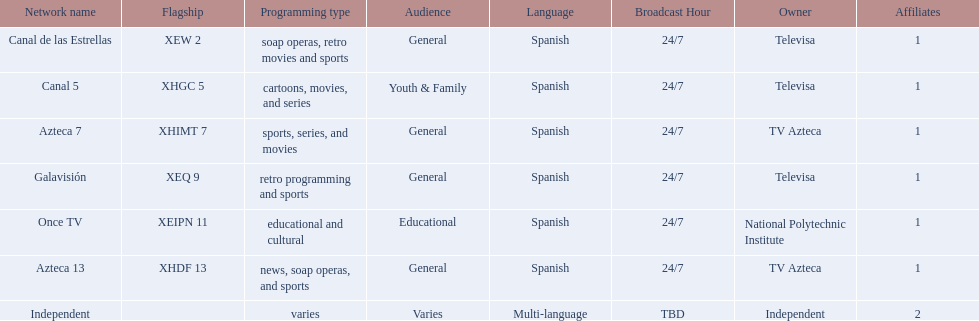What television stations are in morelos? Canal de las Estrellas, Canal 5, Azteca 7, Galavisión, Once TV, Azteca 13, Independent. Of those which network is owned by national polytechnic institute? Once TV. 